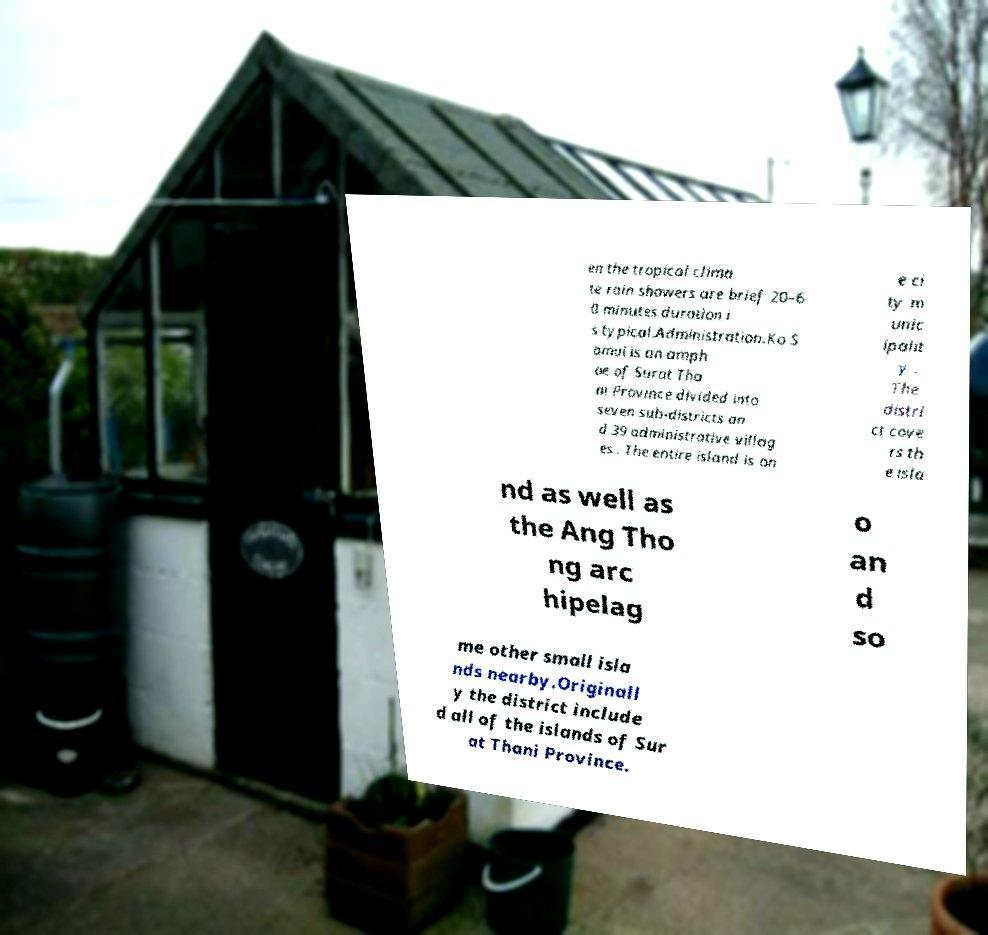Could you extract and type out the text from this image? en the tropical clima te rain showers are brief 20–6 0 minutes duration i s typical.Administration.Ko S amui is an amph oe of Surat Tha ni Province divided into seven sub-districts an d 39 administrative villag es . The entire island is on e ci ty m unic ipalit y . The distri ct cove rs th e isla nd as well as the Ang Tho ng arc hipelag o an d so me other small isla nds nearby.Originall y the district include d all of the islands of Sur at Thani Province. 